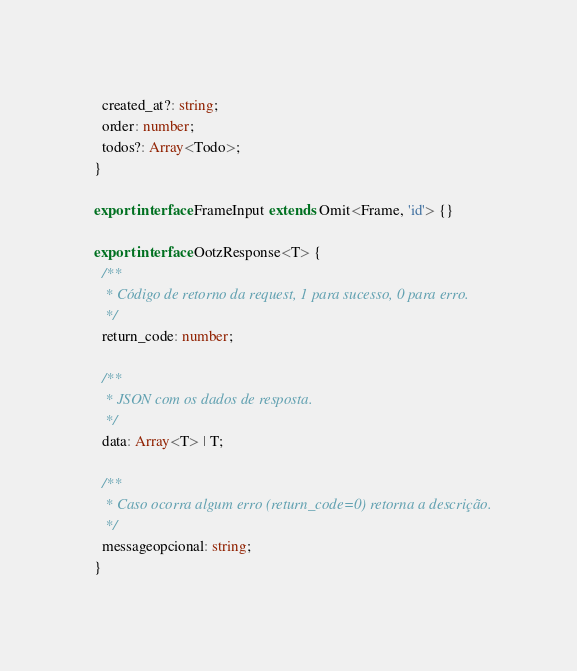<code> <loc_0><loc_0><loc_500><loc_500><_TypeScript_>  created_at?: string;
  order: number;
  todos?: Array<Todo>;
}

export interface FrameInput extends Omit<Frame, 'id'> {}

export interface OotzResponse<T> {
  /**
   * Código de retorno da request, 1 para sucesso, 0 para erro.
   */
  return_code: number;

  /**
   * JSON com os dados de resposta.
   */
  data: Array<T> | T;

  /**
   * Caso ocorra algum erro (return_code=0) retorna a descrição.
   */
  messageopcional: string;
}
</code> 